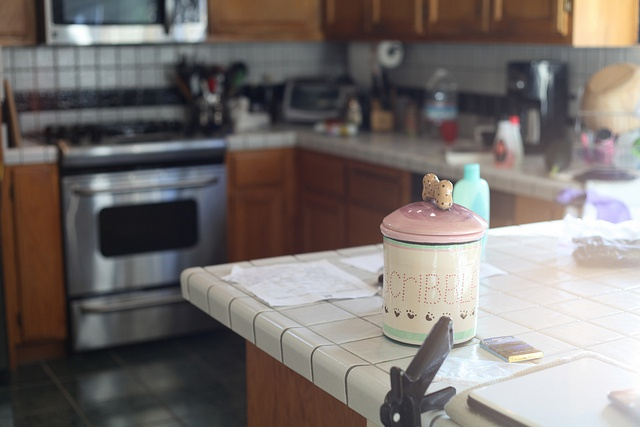Describe the objects in this image and their specific colors. I can see oven in gray, black, and darkgray tones, microwave in gray, lightgray, darkgray, and black tones, bowl in gray, tan, and beige tones, microwave in gray and black tones, and bottle in gray, maroon, and black tones in this image. 